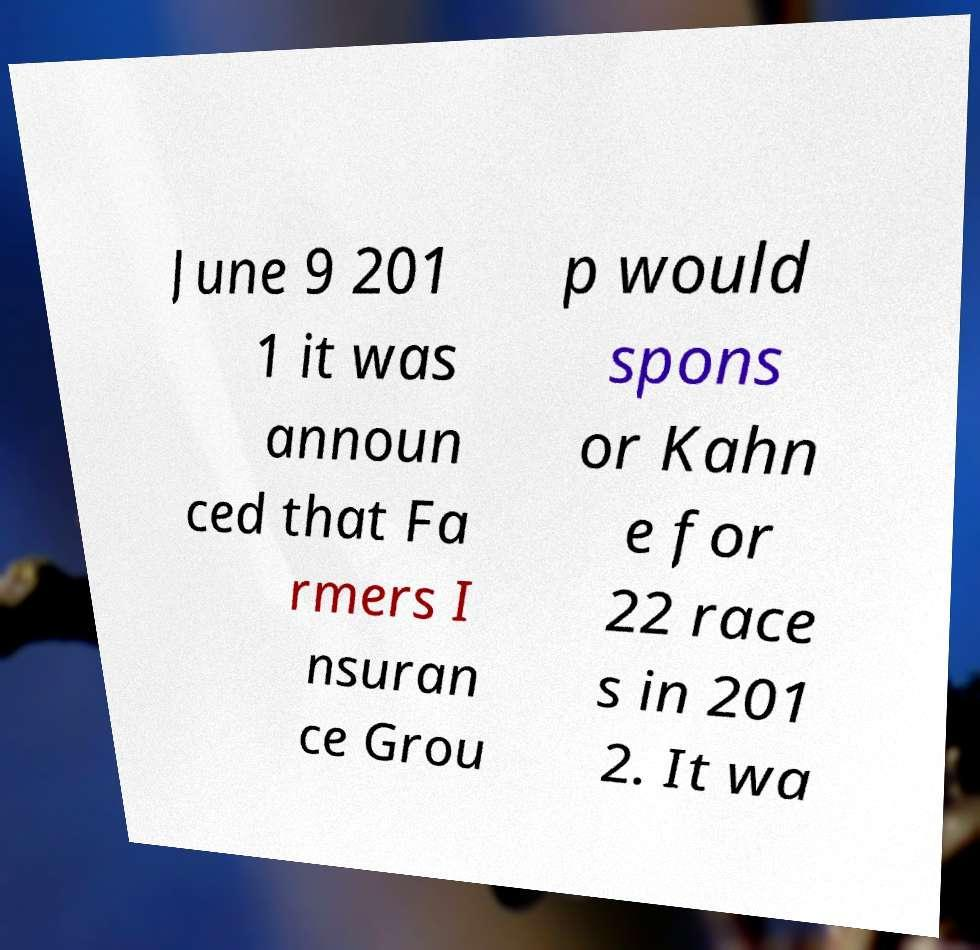Please identify and transcribe the text found in this image. June 9 201 1 it was announ ced that Fa rmers I nsuran ce Grou p would spons or Kahn e for 22 race s in 201 2. It wa 